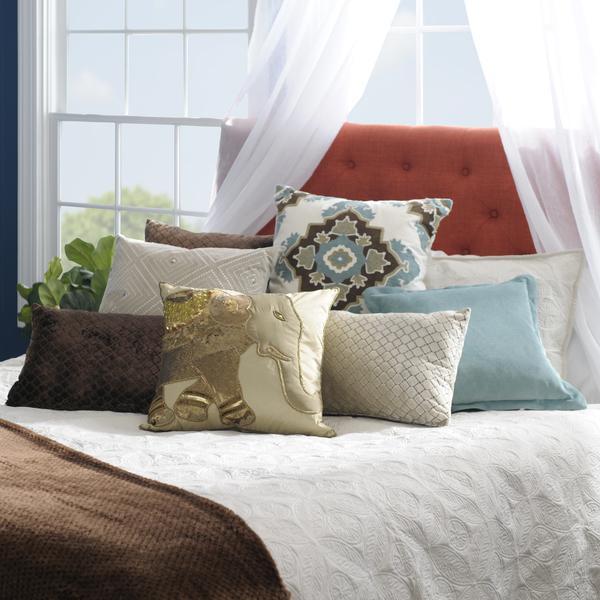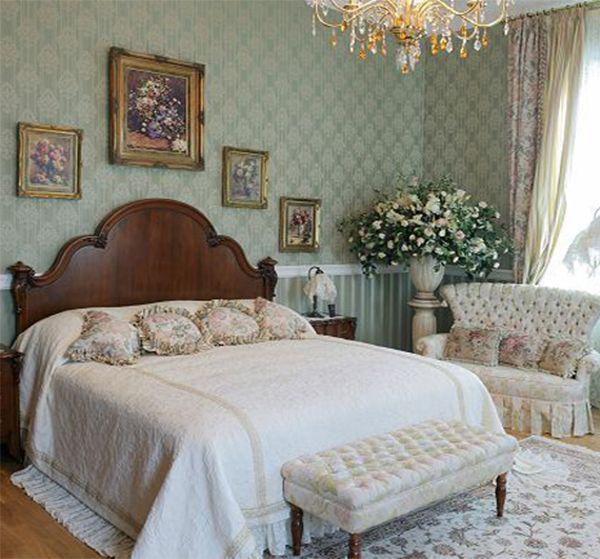The first image is the image on the left, the second image is the image on the right. Evaluate the accuracy of this statement regarding the images: "Two beds, one of them much narrower than the other, have luxurious white and light-colored bedding and pillows.". Is it true? Answer yes or no. No. The first image is the image on the left, the second image is the image on the right. Considering the images on both sides, is "An image features a pillow-piled bed with a neutral-colored tufted headboard." valid? Answer yes or no. No. 